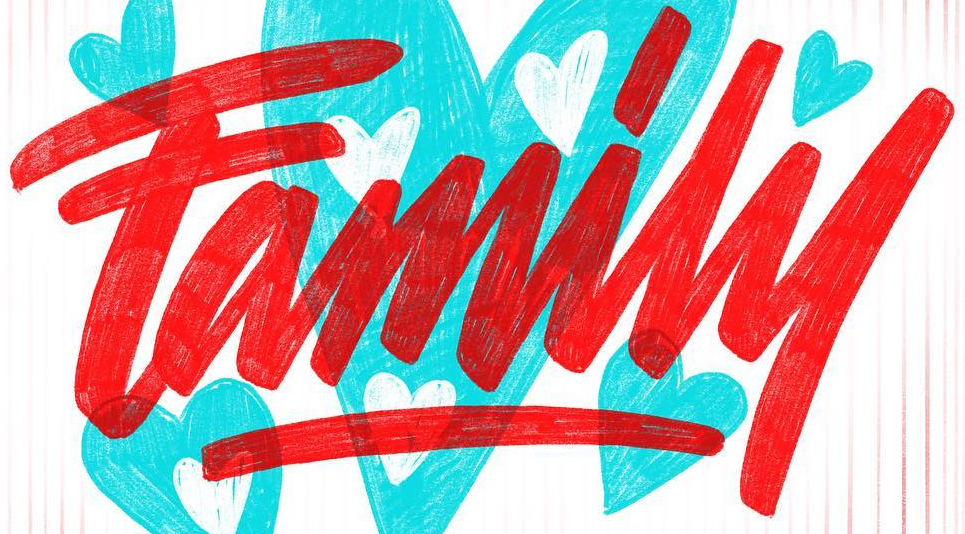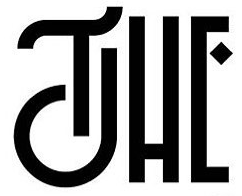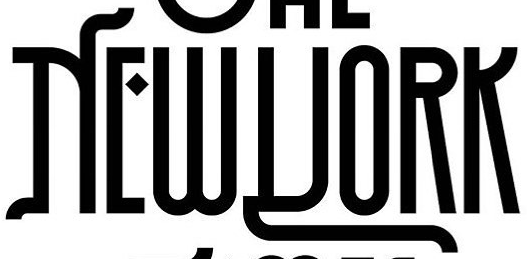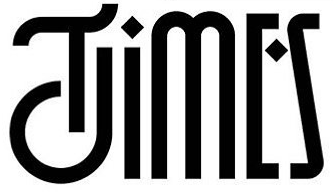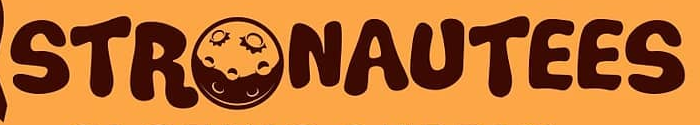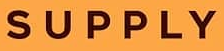What text is displayed in these images sequentially, separated by a semicolon? Family; THE; NEWYORK; TIMES; STRONAUTEES; SUPPLY 